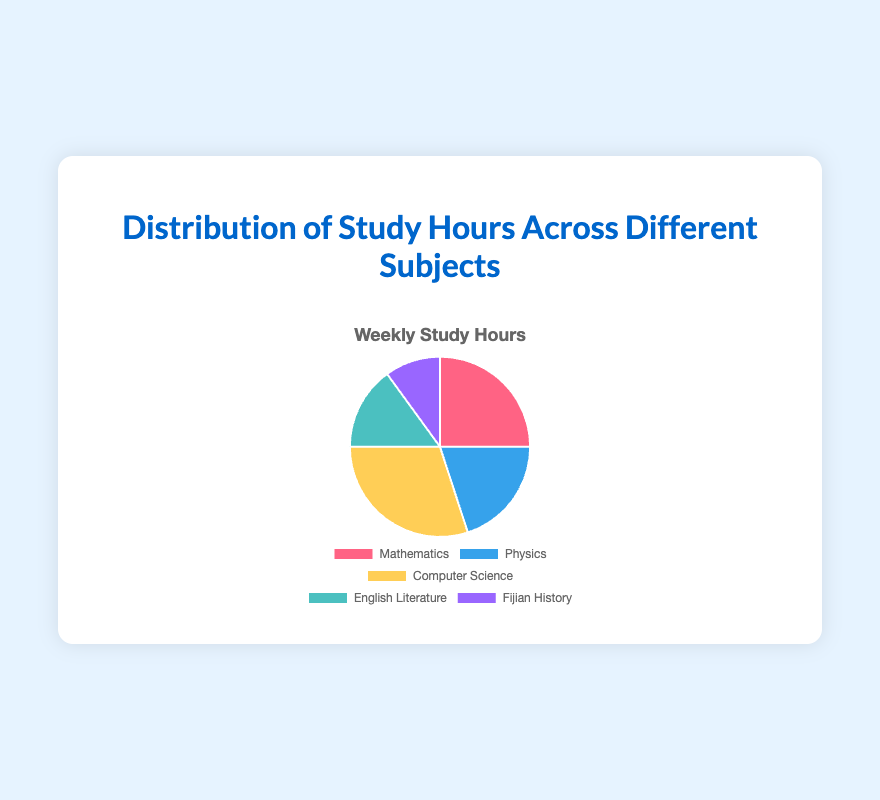What subject has the most study hours? The subject with the largest part of the pie chart represents the most study hours. This is the yellow slice, representing Computer Science with 12 hours.
Answer: Computer Science Which two subjects combined have the same or fewer study hours as Computer Science alone? Computer Science accounts for 12 hours. Combining English Literature (6 hours) and Fijian History (4 hours) gives 10 hours, which is less than 12 hours.
Answer: English Literature and Fijian History How many more hours are spent on Mathematics than Fijian History? Mathematics is 10 hours and Fijian History is 4 hours. Subtracting Fijian History from Mathematics, we get 10 - 4 = 6 hours.
Answer: 6 hours What's the total number of hours spent studying Physics and English Literature? Referring to the pie chart, Physics is 8 hours and English Literature is 6 hours. Adding them, we get 8 + 6 = 14 hours.
Answer: 14 hours Which subject has the smallest portion in the pie chart, and how many hours are devoted to it? The smallest slice is the purple one representing Fijian History with 4 hours.
Answer: Fijian History, 4 hours Which color corresponds with Physics, and how many study hours does it represent? Physics is represented by the blue slice, which shows 8 hours.
Answer: Blue, 8 hours What is the difference in study hours between the subject with the most and the subject with the least amount of study time? The subject with the most study hours is Computer Science (12 hours) and the subject with the least is Fijian History (4 hours). The difference is 12 - 4 = 8 hours.
Answer: 8 hours What percentage of the total study hours is spent on Mathematics? The total hours is 40 (sum of all subjects). Mathematics is 10 hours. The percentage is (10/40) * 100 = 25%.
Answer: 25% Rank the subjects from highest to lowest based on the number of study hours. Computer Science has 12, Mathematics has 10, Physics has 8, English Literature has 6, and Fijian History has 4 hours.
Answer: Computer Science, Mathematics, Physics, English Literature, Fijian History 